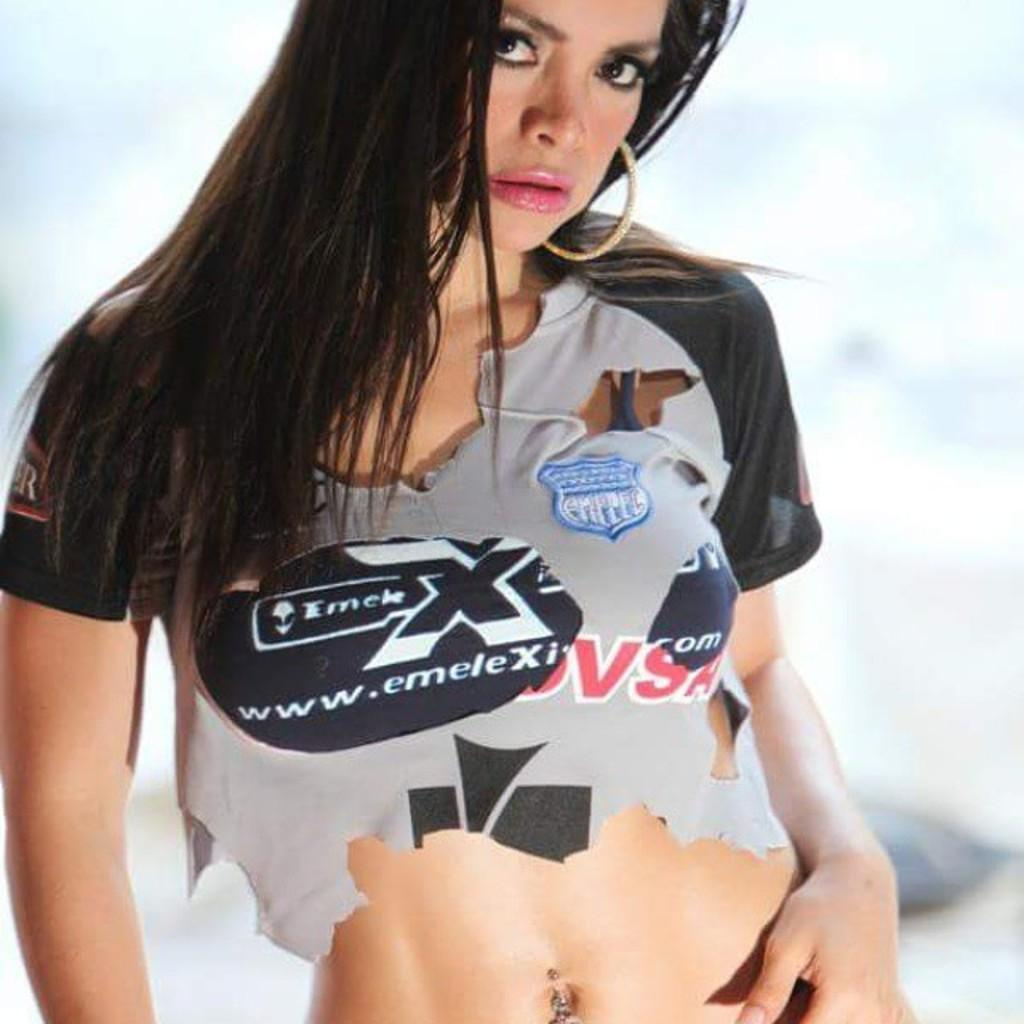<image>
Present a compact description of the photo's key features. A girl with a tattered shirt advertising emeleX. 